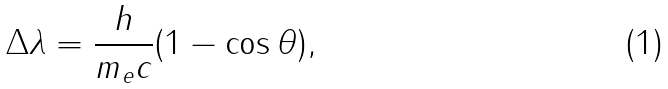Convert formula to latex. <formula><loc_0><loc_0><loc_500><loc_500>\Delta \lambda = { \frac { h } { m _ { e } c } } ( 1 - \cos \theta ) ,</formula> 